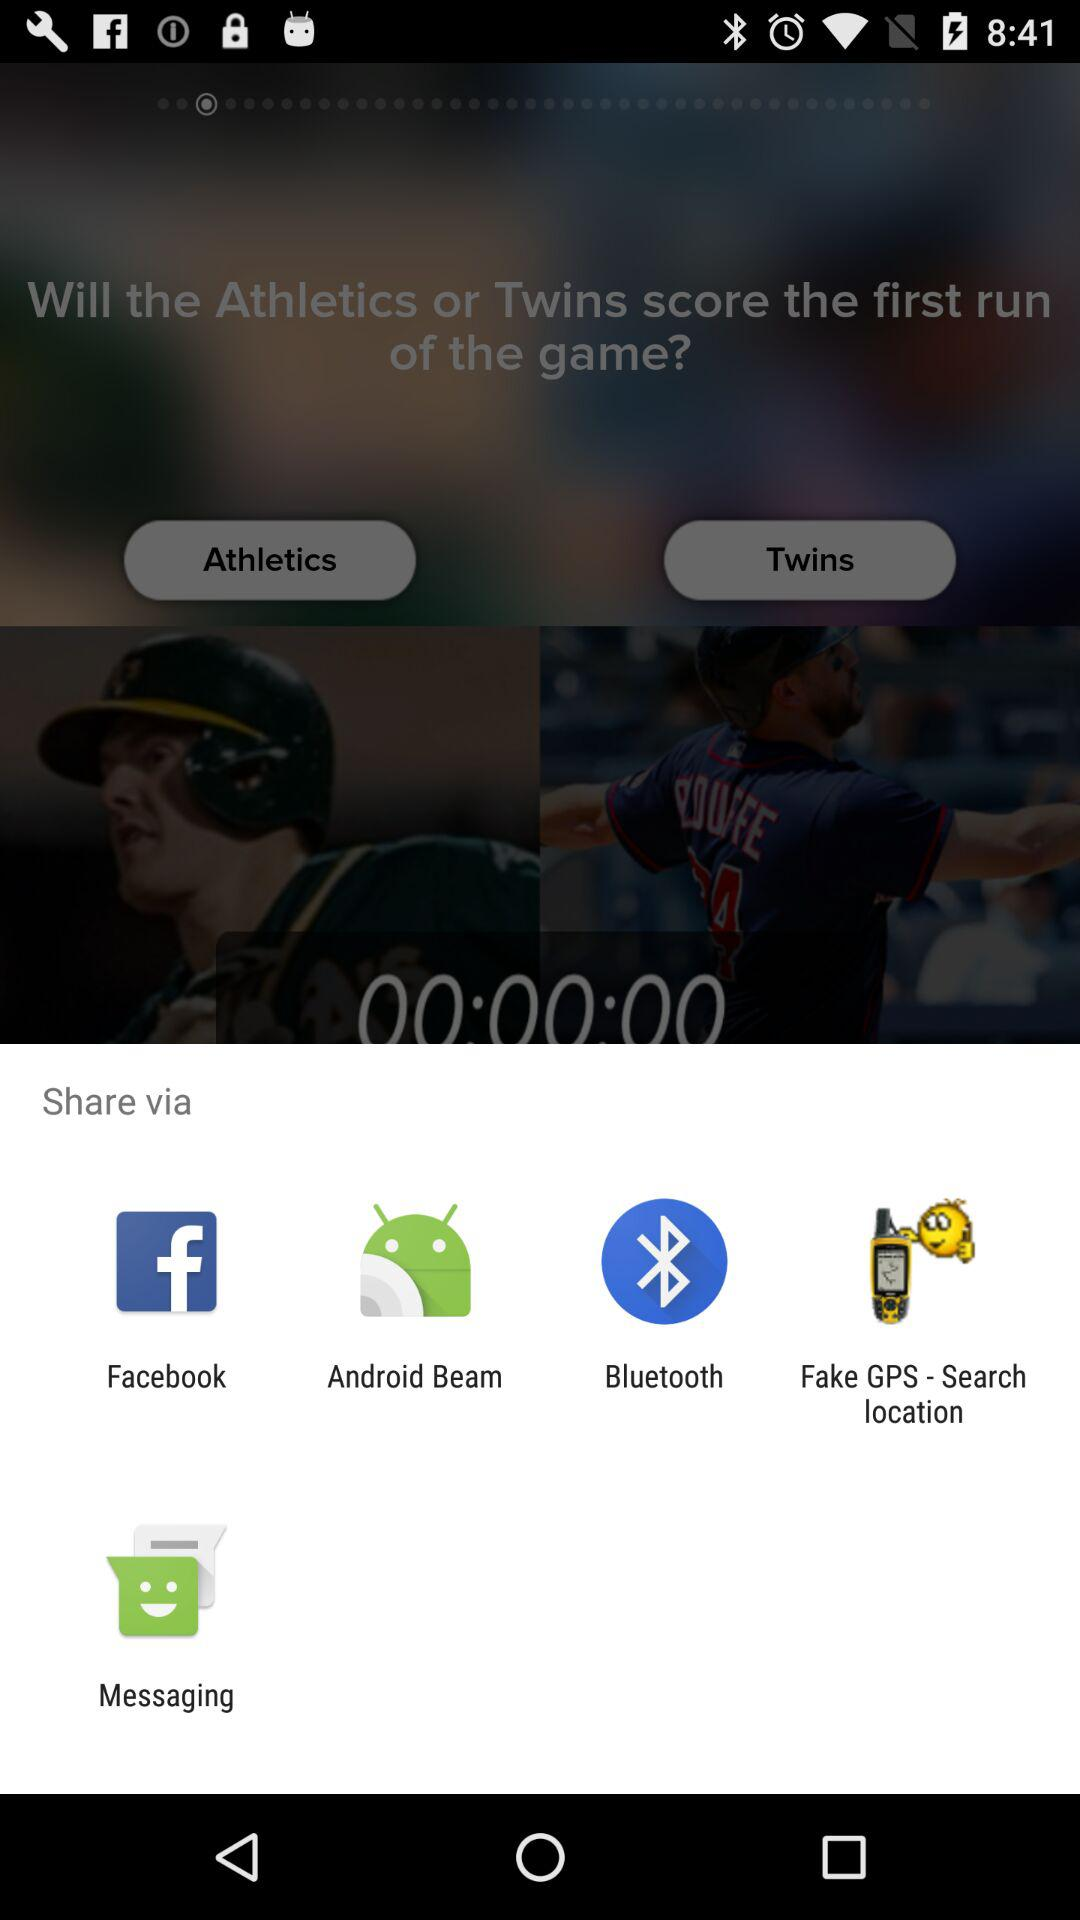How long did it take to score the first run of the game?
When the provided information is insufficient, respond with <no answer>. <no answer> 